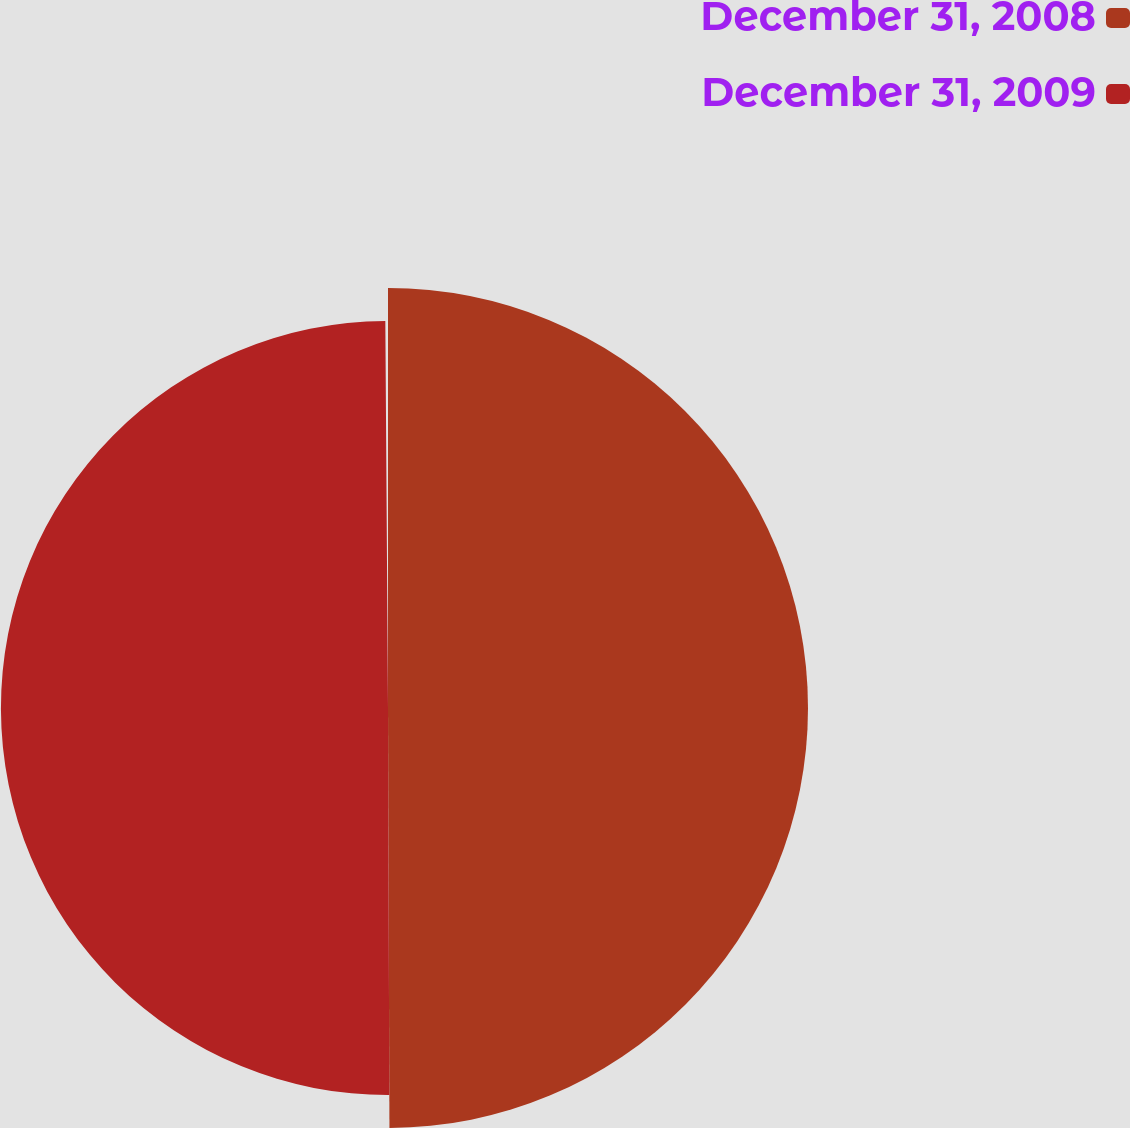Convert chart. <chart><loc_0><loc_0><loc_500><loc_500><pie_chart><fcel>December 31, 2008<fcel>December 31, 2009<nl><fcel>52.04%<fcel>47.96%<nl></chart> 